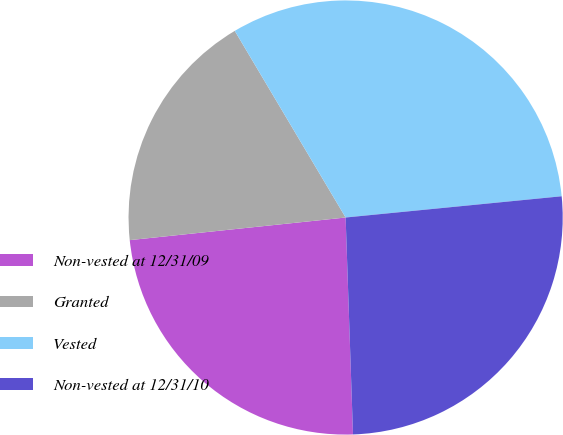<chart> <loc_0><loc_0><loc_500><loc_500><pie_chart><fcel>Non-vested at 12/31/09<fcel>Granted<fcel>Vested<fcel>Non-vested at 12/31/10<nl><fcel>23.88%<fcel>18.13%<fcel>31.97%<fcel>26.02%<nl></chart> 